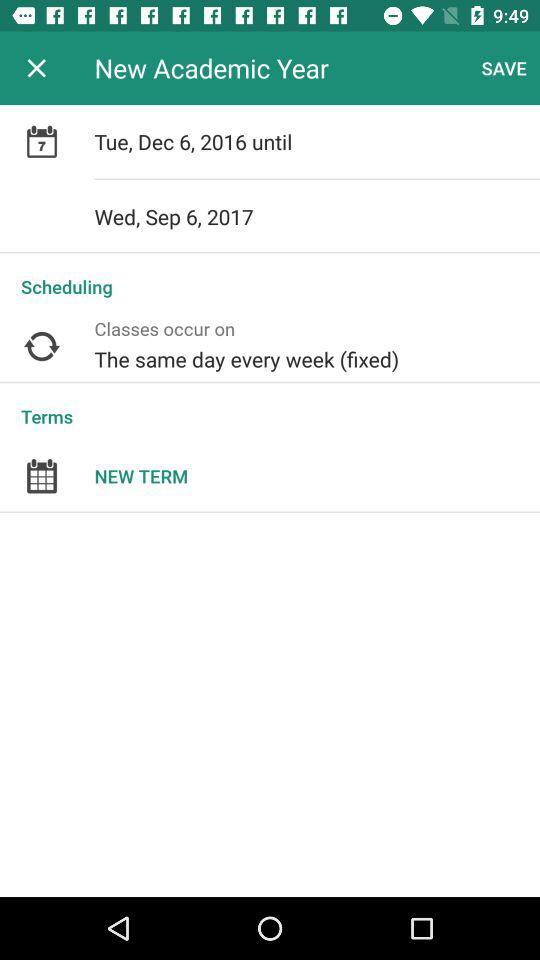What is the schedule of the classes? The schedule of the classes is "The same day every week (fixed)". 